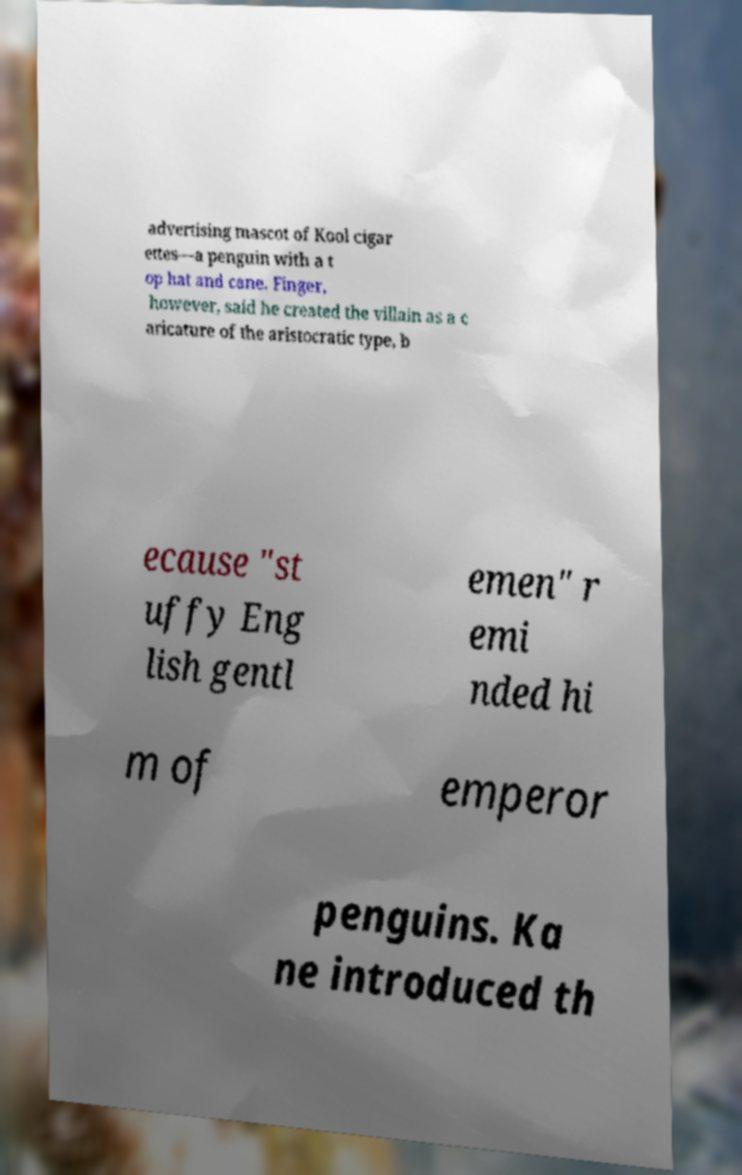Could you assist in decoding the text presented in this image and type it out clearly? advertising mascot of Kool cigar ettes—a penguin with a t op hat and cane. Finger, however, said he created the villain as a c aricature of the aristocratic type, b ecause "st uffy Eng lish gentl emen" r emi nded hi m of emperor penguins. Ka ne introduced th 